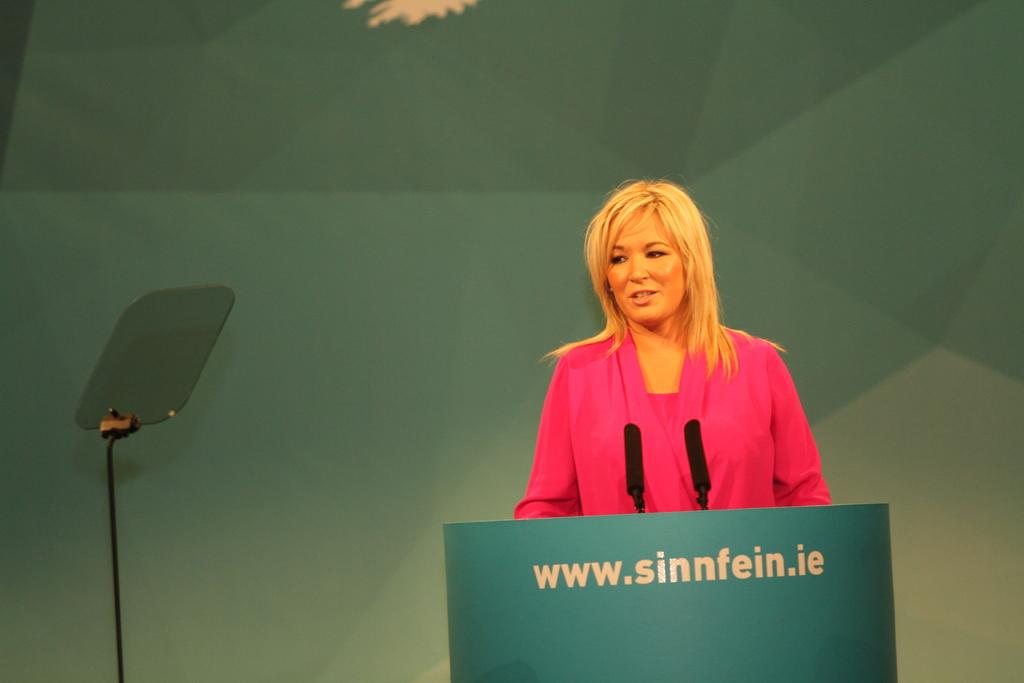Who is present in the image? There is a woman in the image. What is the woman wearing? The woman is wearing a pink dress. What color is the green object in the image? The green object in the image is green. What type of animals can be seen in the image? There are mice in the image. What else can be found in the image besides the woman and mice? There is text written in the image. How many oranges are being observed in the image? There are no oranges present in the image. What is the woman's afterthought about the mice in the image? The image does not provide any information about the woman's thoughts or afterthoughts regarding the mice. 